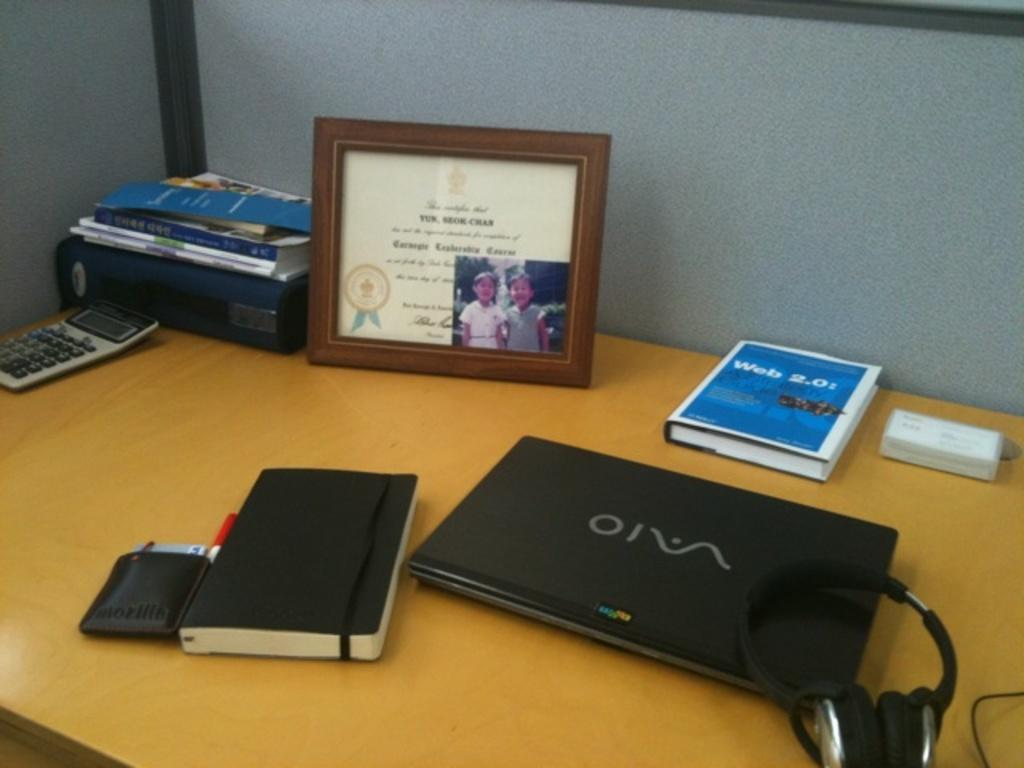<image>
Provide a brief description of the given image. A Vaio laptop sits next to a book titled Web 2.0. 